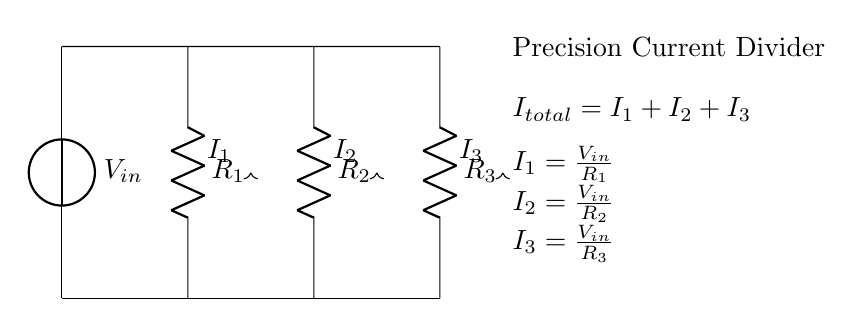What is the input voltage of this circuit? The input voltage is labeled as \( V_{in} \) at the source, indicating it supplies the circuit.
Answer: \( V_{in} \) How many resistors are present in this current divider? There are three resistors in the current divider circuit as indicated by the three \( R \) components in the diagram.
Answer: 3 What is the total current in the circuit? The total current is given by the equation \( I_{total} = I_1 + I_2 + I_3 \) as stated in the circuit diagram.
Answer: \( I_{total} \) How does the current distribute amongst the resistors? The currents through the resistors are defined as \( I_1 = \frac{V_{in}}{R_1} \), \( I_2 = \frac{V_{in}}{R_2} \), and \( I_3 = \frac{V_{in}}{R_3} \), illustrating how \( V_{in} \) over each resistance determines the current through that resistor.
Answer: Based on resistance values If \( R_2 \) is halved, how does \( I_2 \) change? Halving \( R_2 \) would double \( I_2 \) since \( I_2 = \frac{V_{in}}{R_2} \), indicating an inverse relationship between current and resistance.
Answer: Doubles What principle does this circuit demonstrate? This circuit demonstrates the current divider principle, where the input current is divided into smaller currents through multiple paths defined by resistor values.
Answer: Current divider principle What happens to the total current if \( R_1 \) is very large? If \( R_1 \) is very large, \( I_1 \) approaches zero, resulting in almost all the input current flowing through the other resistors \( R_2 \) and \( R_3 \), depending on their resistances.
Answer: \( I_1 \to 0 \) 